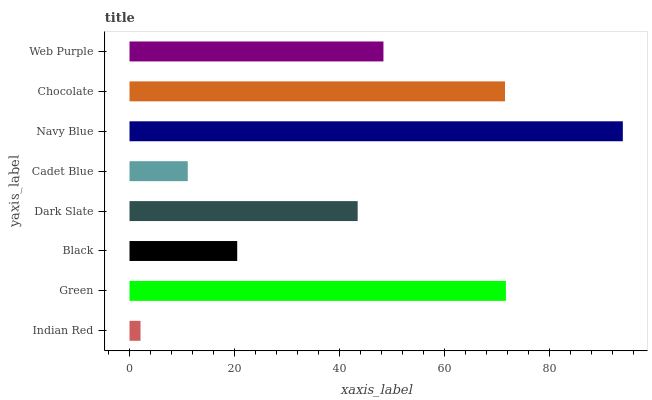Is Indian Red the minimum?
Answer yes or no. Yes. Is Navy Blue the maximum?
Answer yes or no. Yes. Is Green the minimum?
Answer yes or no. No. Is Green the maximum?
Answer yes or no. No. Is Green greater than Indian Red?
Answer yes or no. Yes. Is Indian Red less than Green?
Answer yes or no. Yes. Is Indian Red greater than Green?
Answer yes or no. No. Is Green less than Indian Red?
Answer yes or no. No. Is Web Purple the high median?
Answer yes or no. Yes. Is Dark Slate the low median?
Answer yes or no. Yes. Is Cadet Blue the high median?
Answer yes or no. No. Is Chocolate the low median?
Answer yes or no. No. 